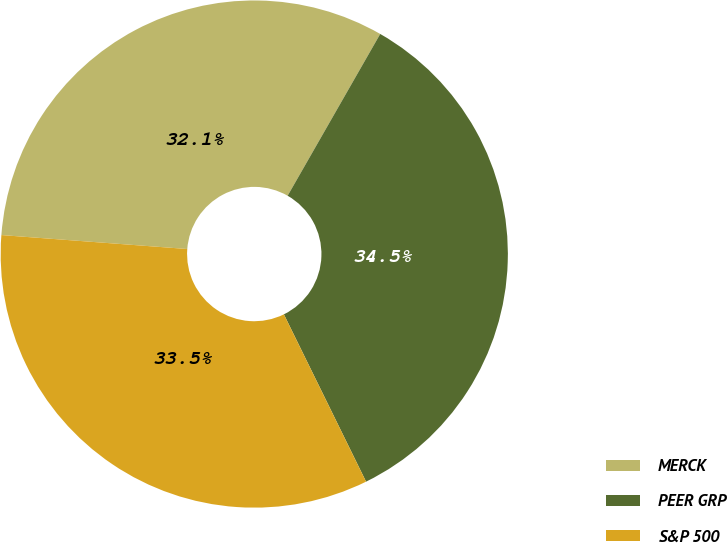Convert chart. <chart><loc_0><loc_0><loc_500><loc_500><pie_chart><fcel>MERCK<fcel>PEER GRP<fcel>S&P 500<nl><fcel>32.08%<fcel>34.46%<fcel>33.46%<nl></chart> 